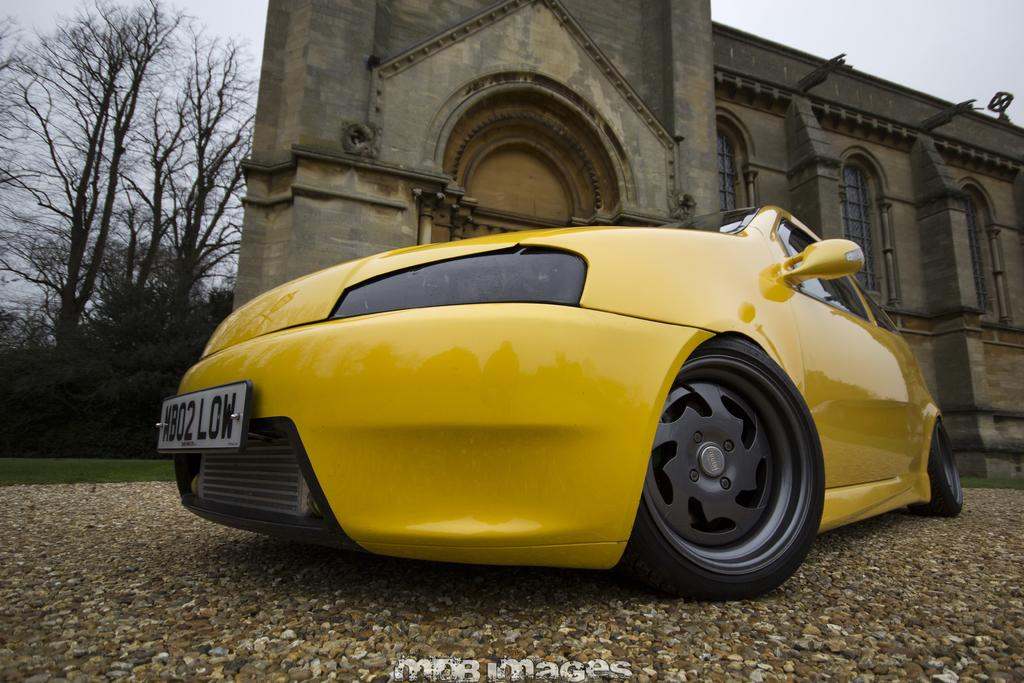What color is the car in the image? The car in the image is yellow. What is the car resting on in the image? The car is on a surface in the image. What type of structure can be seen in the image? There is a building in the image. What type of vegetation is visible in the background of the image? There is grass and trees visible in the background of the image. What part of the natural environment is visible in the image? The sky is visible in the background of the image. What is written or displayed at the bottom of the image? There is text at the bottom of the image. How many books are stacked on the oven in the image? There is no oven or books present in the image. 